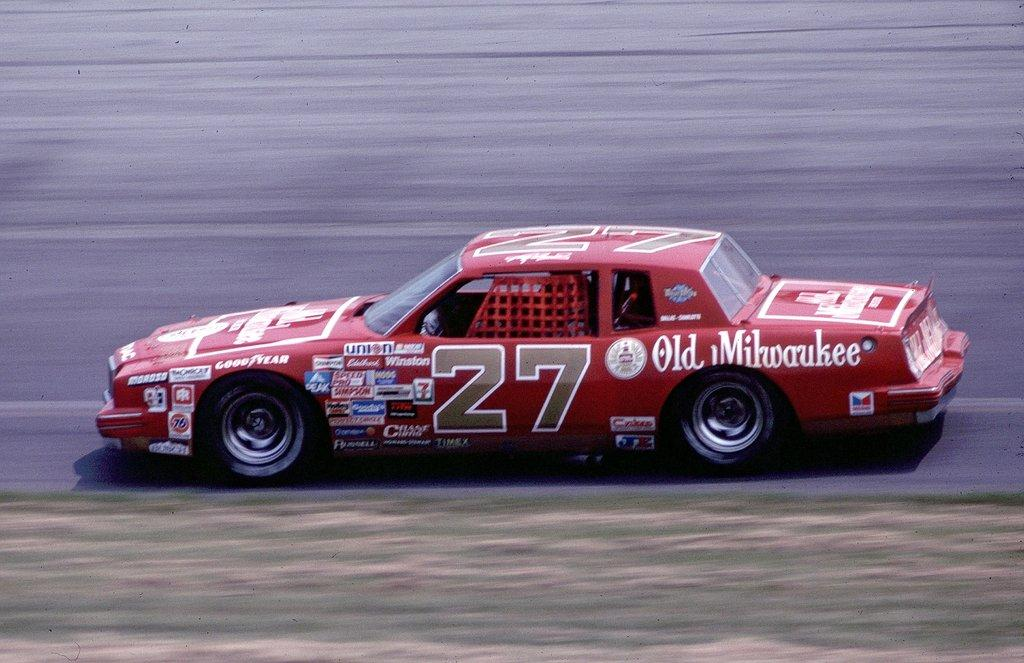What color is the car in the image? The car in the image is red. What is the car doing in the image? The car is moving on the road. Where is the nearest cemetery to the car in the image? There is no information about the location of a cemetery in the image, so it cannot be determined. 